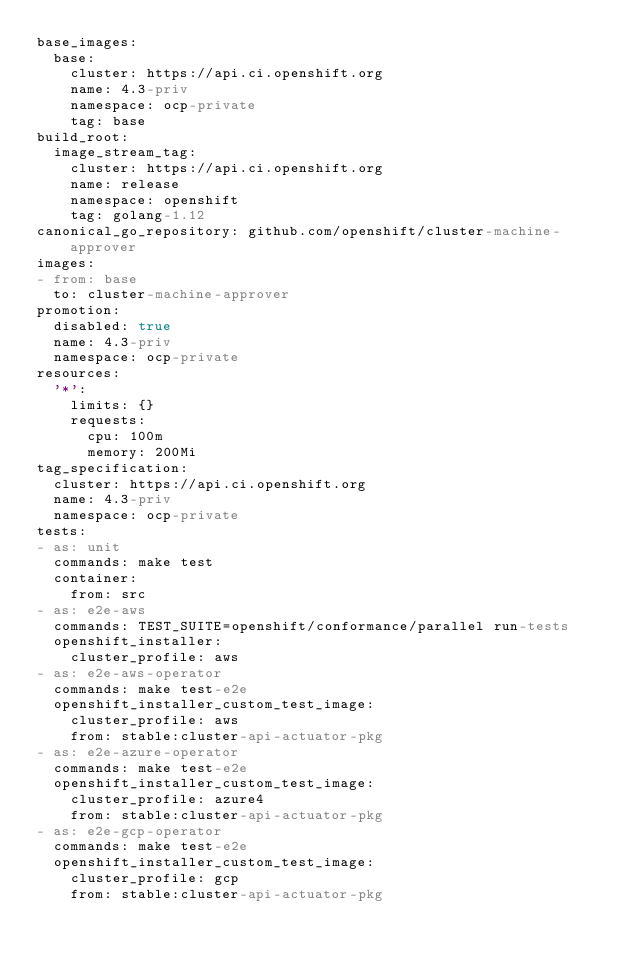Convert code to text. <code><loc_0><loc_0><loc_500><loc_500><_YAML_>base_images:
  base:
    cluster: https://api.ci.openshift.org
    name: 4.3-priv
    namespace: ocp-private
    tag: base
build_root:
  image_stream_tag:
    cluster: https://api.ci.openshift.org
    name: release
    namespace: openshift
    tag: golang-1.12
canonical_go_repository: github.com/openshift/cluster-machine-approver
images:
- from: base
  to: cluster-machine-approver
promotion:
  disabled: true
  name: 4.3-priv
  namespace: ocp-private
resources:
  '*':
    limits: {}
    requests:
      cpu: 100m
      memory: 200Mi
tag_specification:
  cluster: https://api.ci.openshift.org
  name: 4.3-priv
  namespace: ocp-private
tests:
- as: unit
  commands: make test
  container:
    from: src
- as: e2e-aws
  commands: TEST_SUITE=openshift/conformance/parallel run-tests
  openshift_installer:
    cluster_profile: aws
- as: e2e-aws-operator
  commands: make test-e2e
  openshift_installer_custom_test_image:
    cluster_profile: aws
    from: stable:cluster-api-actuator-pkg
- as: e2e-azure-operator
  commands: make test-e2e
  openshift_installer_custom_test_image:
    cluster_profile: azure4
    from: stable:cluster-api-actuator-pkg
- as: e2e-gcp-operator
  commands: make test-e2e
  openshift_installer_custom_test_image:
    cluster_profile: gcp
    from: stable:cluster-api-actuator-pkg
</code> 